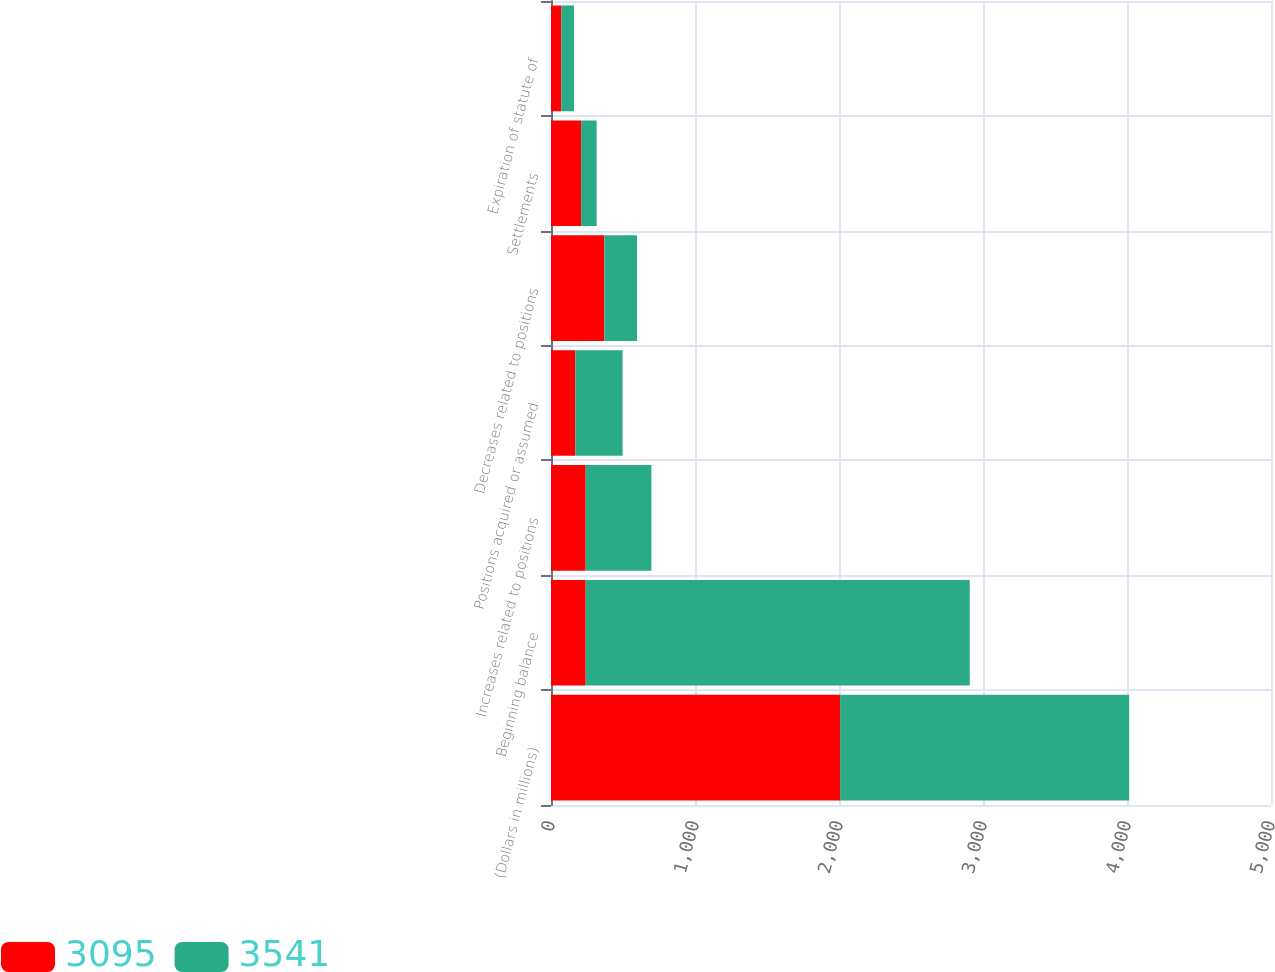Convert chart. <chart><loc_0><loc_0><loc_500><loc_500><stacked_bar_chart><ecel><fcel>(Dollars in millions)<fcel>Beginning balance<fcel>Increases related to positions<fcel>Positions acquired or assumed<fcel>Decreases related to positions<fcel>Settlements<fcel>Expiration of statute of<nl><fcel>3095<fcel>2008<fcel>241<fcel>241<fcel>169<fcel>371<fcel>209<fcel>72<nl><fcel>3541<fcel>2007<fcel>2667<fcel>456<fcel>328<fcel>227<fcel>108<fcel>88<nl></chart> 